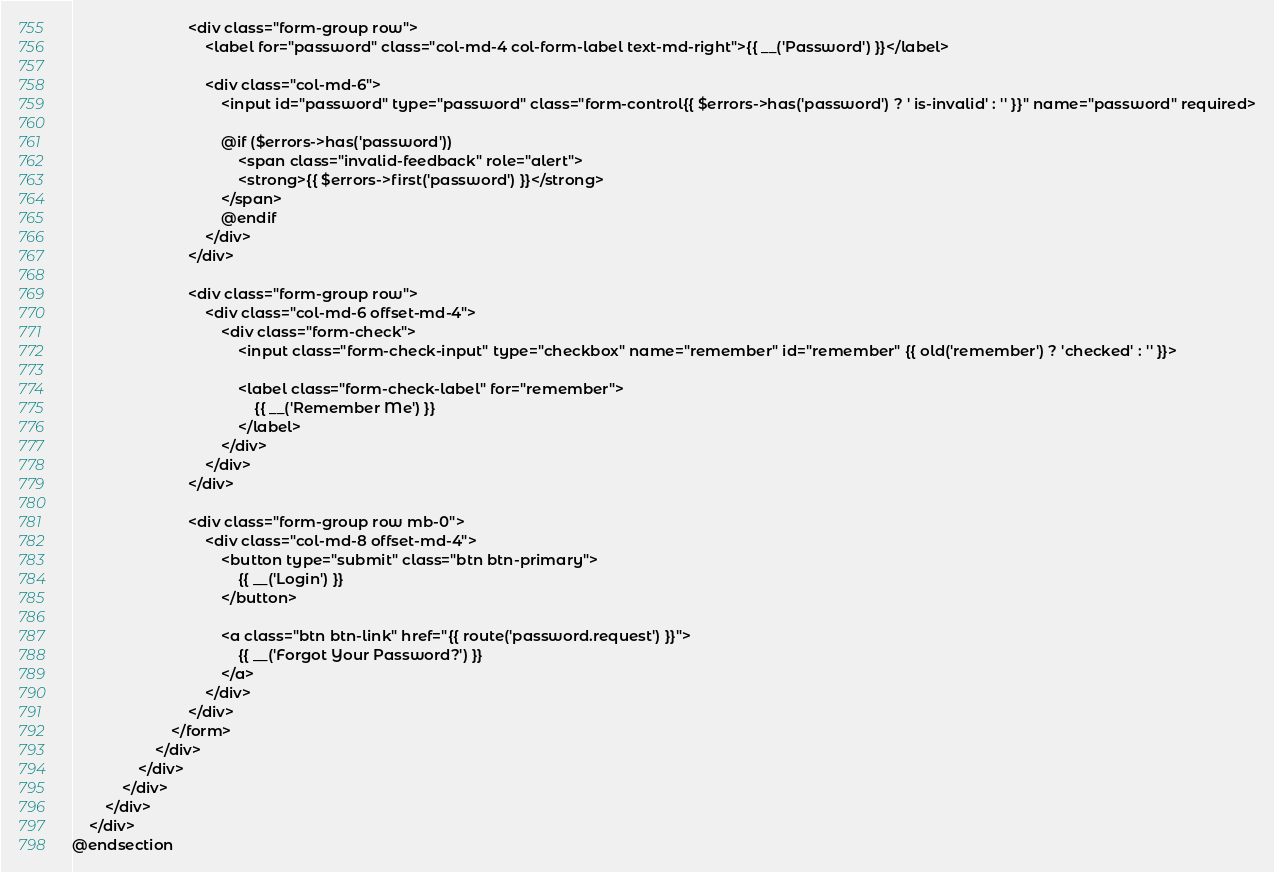Convert code to text. <code><loc_0><loc_0><loc_500><loc_500><_PHP_>							<div class="form-group row">
								<label for="password" class="col-md-4 col-form-label text-md-right">{{ __('Password') }}</label>

								<div class="col-md-6">
									<input id="password" type="password" class="form-control{{ $errors->has('password') ? ' is-invalid' : '' }}" name="password" required>

									@if ($errors->has('password'))
										<span class="invalid-feedback" role="alert">
                                        <strong>{{ $errors->first('password') }}</strong>
                                    </span>
									@endif
								</div>
							</div>

							<div class="form-group row">
								<div class="col-md-6 offset-md-4">
									<div class="form-check">
										<input class="form-check-input" type="checkbox" name="remember" id="remember" {{ old('remember') ? 'checked' : '' }}>

										<label class="form-check-label" for="remember">
											{{ __('Remember Me') }}
										</label>
									</div>
								</div>
							</div>

							<div class="form-group row mb-0">
								<div class="col-md-8 offset-md-4">
									<button type="submit" class="btn btn-primary">
										{{ __('Login') }}
									</button>

									<a class="btn btn-link" href="{{ route('password.request') }}">
										{{ __('Forgot Your Password?') }}
									</a>
								</div>
							</div>
						</form>
					</div>
				</div>
			</div>
		</div>
	</div>
@endsection
</code> 